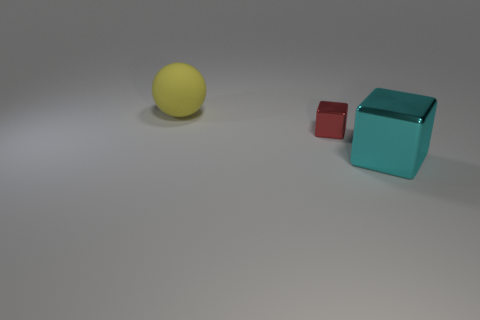Are there any other things that have the same shape as the yellow matte thing?
Offer a terse response. No. Are there an equal number of cyan things that are left of the tiny metallic block and green cylinders?
Offer a terse response. Yes. Does the yellow object have the same size as the block on the left side of the cyan metal object?
Your response must be concise. No. What number of other objects are there of the same size as the yellow thing?
Offer a terse response. 1. What number of other objects are the same color as the big rubber sphere?
Provide a short and direct response. 0. Are there any other things that are the same size as the red metal cube?
Offer a very short reply. No. How many other objects are there of the same shape as the yellow thing?
Provide a succinct answer. 0. Do the cyan metal thing and the red metallic object have the same size?
Your answer should be very brief. No. Is there a large purple matte object?
Ensure brevity in your answer.  No. Is there anything else that has the same material as the big ball?
Your answer should be compact. No. 